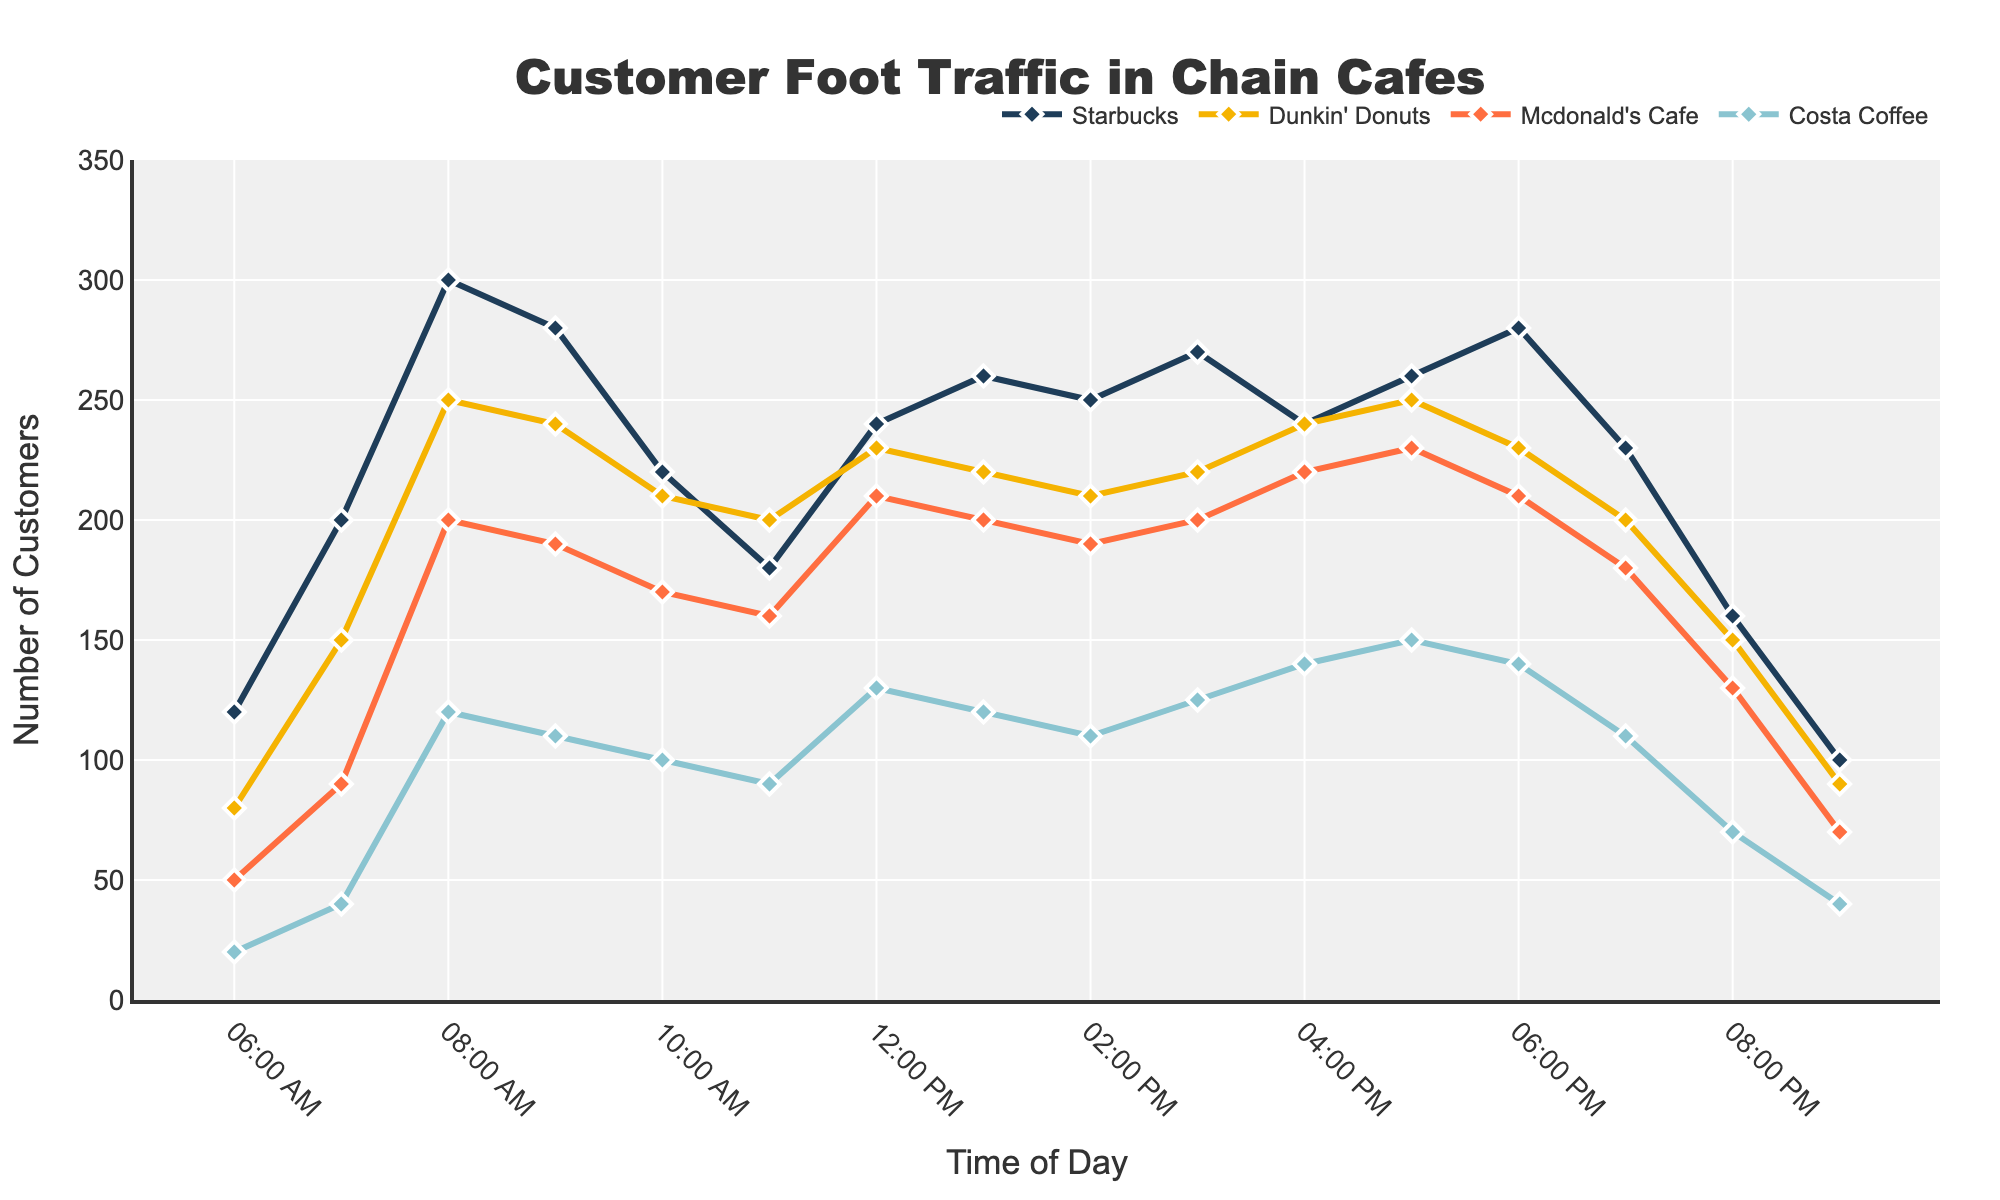What is the title of the plot? The title is usually located at the top of a plot and in this figure, it reads 'Customer Foot Traffic in Chain Cafes'.
Answer: Customer Foot Traffic in Chain Cafes What is the time with the highest customer count at Starbucks? By examining the plot, we observe that the highest point for Starbucks occurs at 8:00 AM.
Answer: 8:00 AM Which cafe has the fewest customers at 6:00 PM? Observing the plot at 6:00 PM, we compare the points of all cafes: Starbucks, Dunkin' Donuts, McDonald's Cafe, and Costa Coffee. Costa Coffee has the lowest value.
Answer: Costa Coffee At what times do all cafes experience a noticeable dip in customer traffic? By tracing the lines for all cafes, we notice a significant dip around 9:00 PM.
Answer: 9:00 PM How does the customer traffic at Dunkin' Donuts at 7:00 AM compare to McDonald's Cafe at 7:00 AM? At 7:00 AM, the plot shows Dunkin' Donuts has 150 customers while McDonald's Cafe has 90 customers; so Dunkin' Donuts has more.
Answer: More Which cafe shows the most consistent customer traffic throughout the day? By visually comparing the fluctuations of each line, we see that Dunkin' Donuts has the least variation, indicating consistency.
Answer: Dunkin' Donuts What is the average customer count at Costa Coffee between 6:00 AM and 10:00 AM? Add the values for Costa Coffee (20 + 40 + 120 + 110) and divide by the number of data points (4). This equals 290 / 4 = 72.5.
Answer: 72.5 Between what hours does Starbucks experience a steady rise in customer foot traffic? We observe the increasing trend for Starbucks from 6:00 AM to 8:00 AM.
Answer: 6:00 AM to 8:00 AM Compare the customer foot traffic at noon across all cafes. Which cafe had the highest count? At 12:00 PM, compare the points of all cafes: Starbucks, Dunkin' Donuts, McDonald's Cafe, and Costa Coffee. McDonald's Cafe has the most with 210.
Answer: McDonald's Cafe What are the peak hours for customer traffic for McDonald's Cafe? Observing McDonald's Cafe curve, the highest point happens at 5:00 PM.
Answer: 5:00 PM 